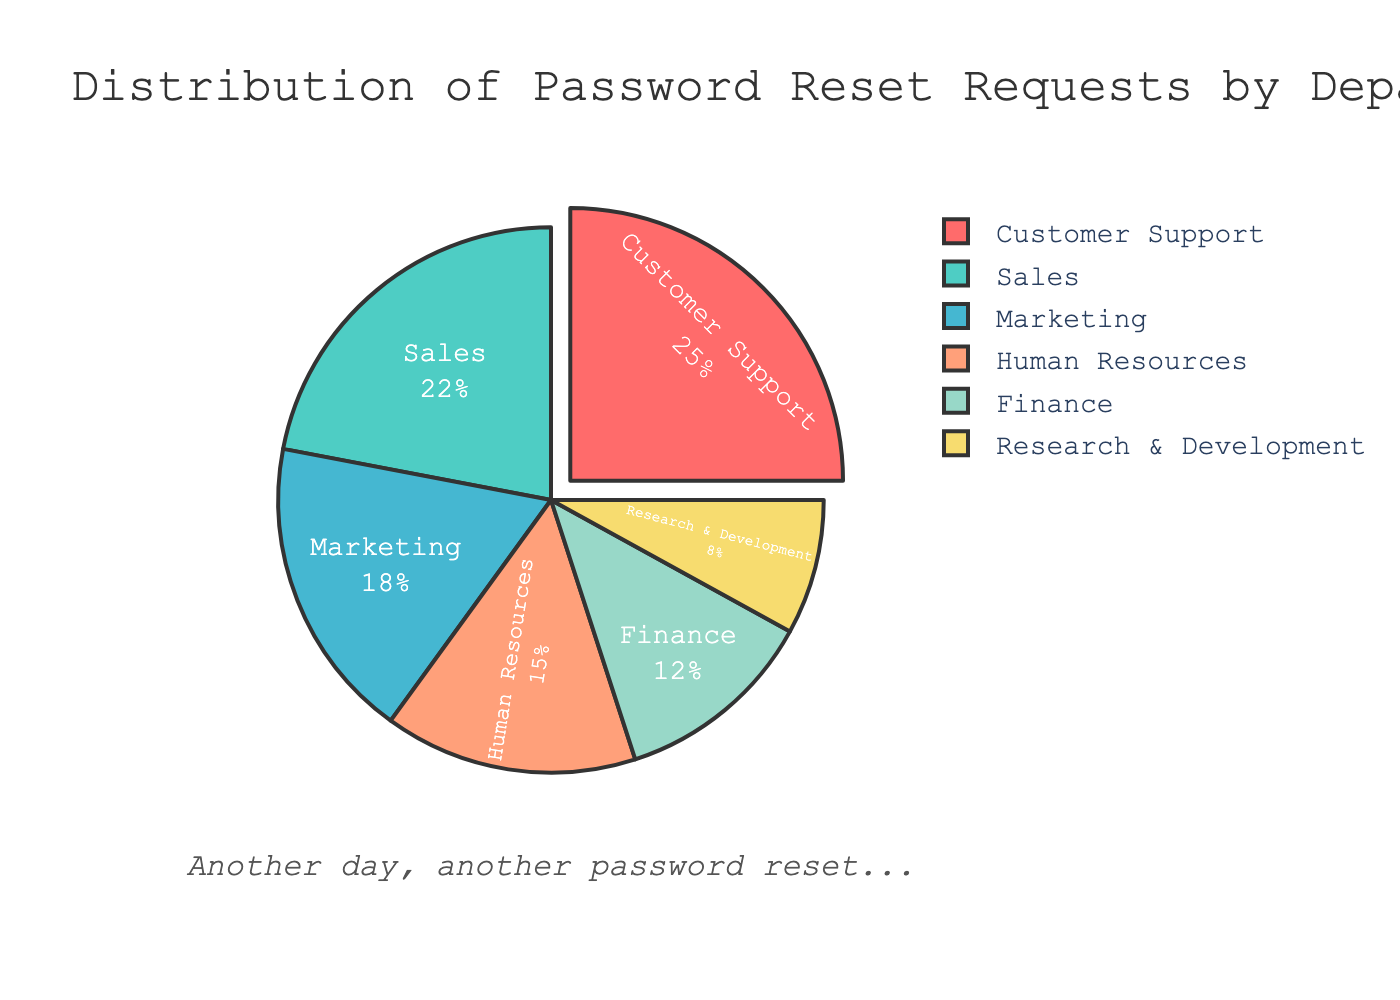Which department has the highest percentage of password reset requests? By observing the pie chart, the section representing Customer Support is the largest at 25%, indicating the highest percentage.
Answer: Customer Support Which department has the smallest share of password reset requests? The section of the pie chart representing Research & Development is the smallest, with a percentage of 8%.
Answer: Research & Development How much greater is the percentage of reset requests in Sales compared to Finance? The pie chart shows Sales has 22% and Finance has 12%. The difference is calculated as 22% - 12% = 10%.
Answer: 10% What is the combined percentage of password reset requests for Human Resources and Marketing? The pie chart shows that Human Resources has 15% and Marketing has 18%. Summing these up gives 15% + 18% = 33%.
Answer: 33% Which departments have a percentage of password reset requests greater than 20%? From the pie chart, Customer Support (25%) and Sales (22%) both have percentages greater than 20%.
Answer: Customer Support, Sales What is the average percentage of password reset requests for Research & Development, Finance, and Marketing? Adding the percentages from the pie chart for Research & Development (8%), Finance (12%), and Marketing (18%) gives 8% + 12% + 18% = 38%. The average is calculated as 38% / 3 = 12.67%.
Answer: 12.67% How does the percentage of password reset requests in Customer Support compare with Marketing? The Customer Support percentage in the pie chart is 25%, while Marketing is 18%. Comparing these, 25% is greater than 18%.
Answer: Customer Support > Marketing Which sections of the pie chart are visually pulled out (separated) from the rest of the pie, indicating emphasis? Observing the pie chart, the only section that is visually pulled out is Customer Support, indicating an emphasis on its higher percentage.
Answer: Customer Support What percentage of password reset requests do the Sales and Finance departments account for combined? The pie chart shows Sales at 22% and Finance at 12%. Adding these percentages gives 22% + 12% = 34%.
Answer: 34% 